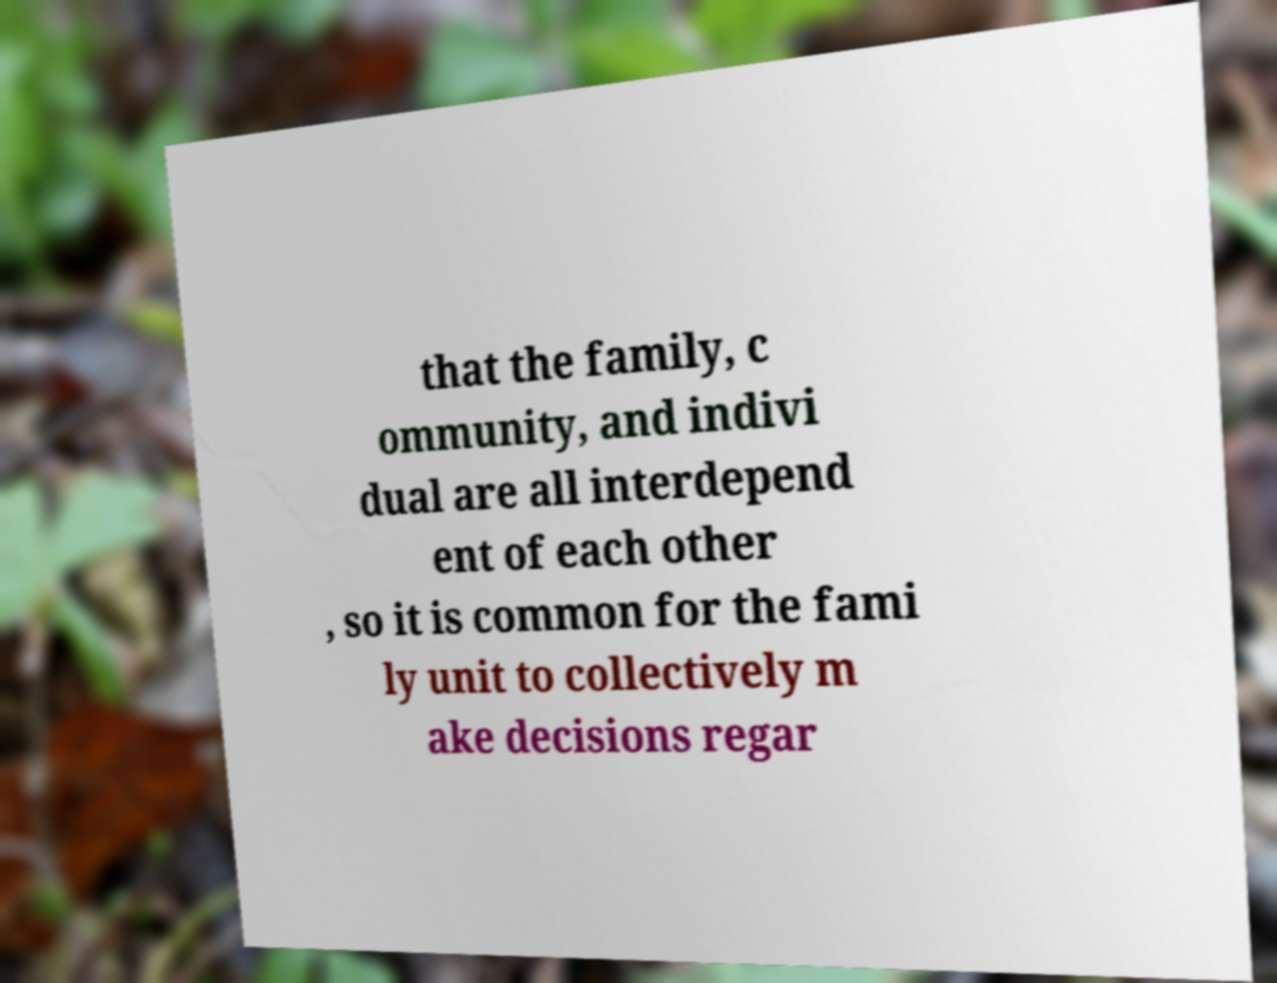What messages or text are displayed in this image? I need them in a readable, typed format. that the family, c ommunity, and indivi dual are all interdepend ent of each other , so it is common for the fami ly unit to collectively m ake decisions regar 